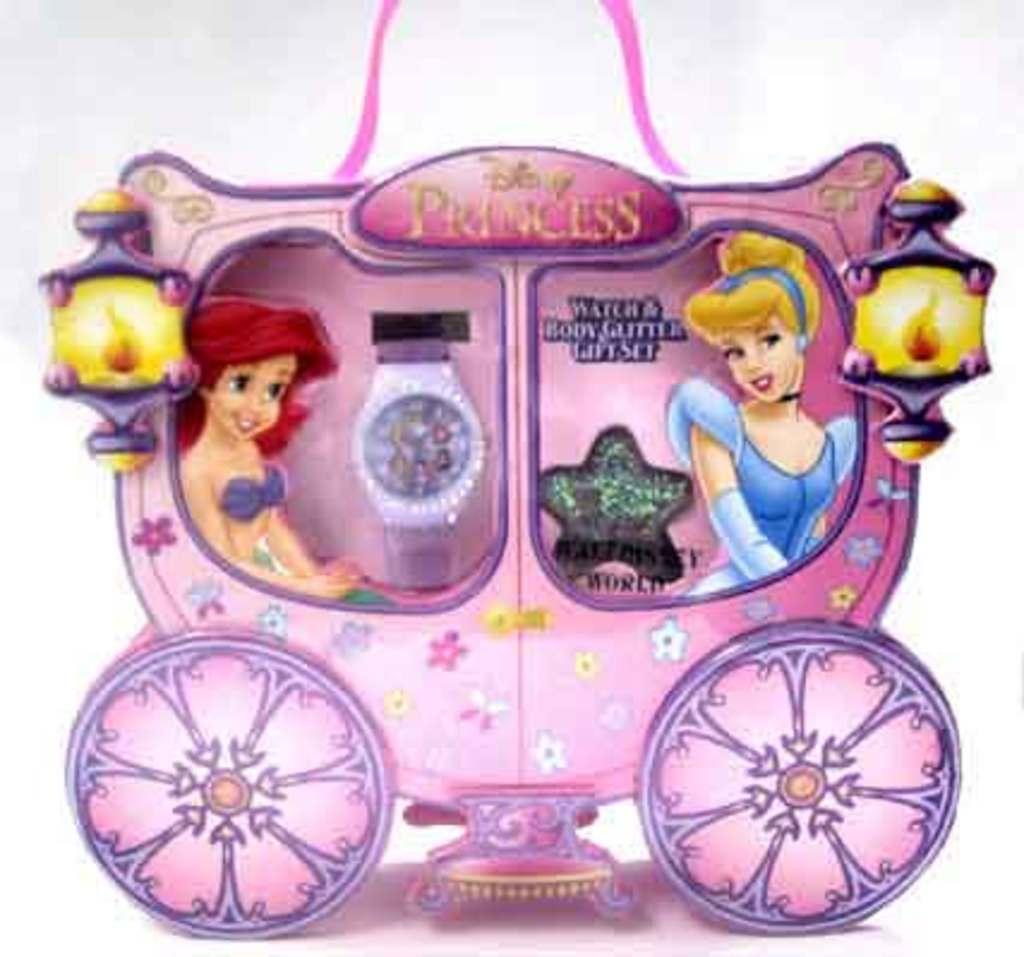What kind of princesses are these?
Offer a very short reply. Disney. 